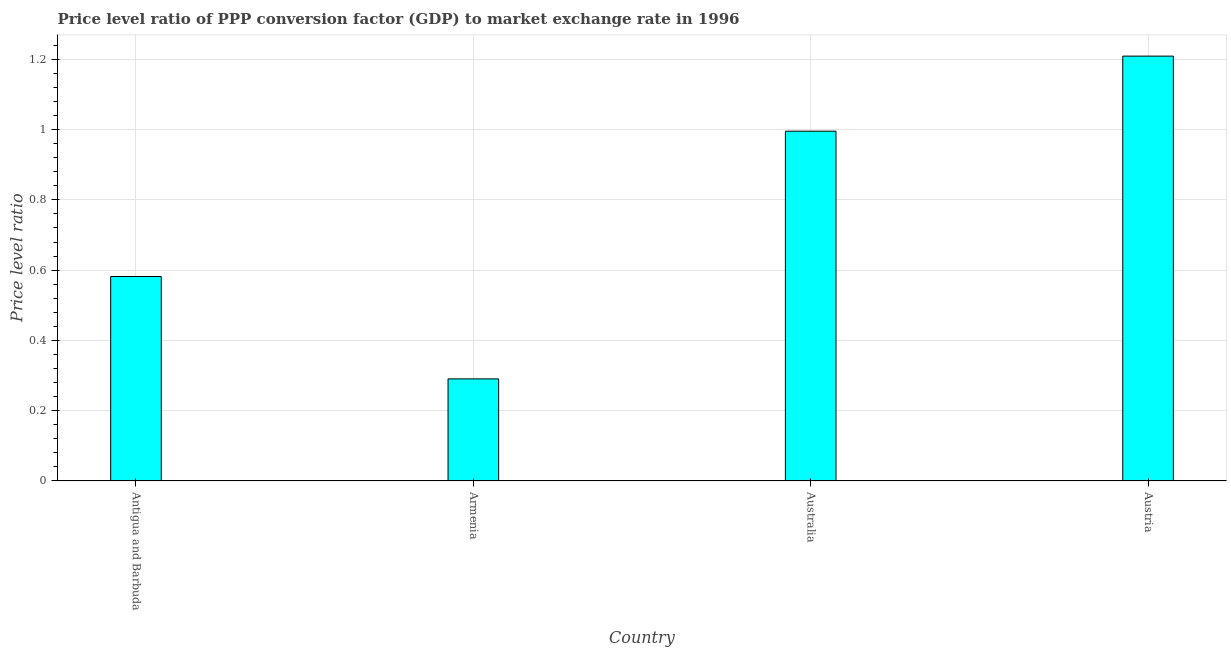Does the graph contain any zero values?
Your answer should be very brief. No. Does the graph contain grids?
Keep it short and to the point. Yes. What is the title of the graph?
Your answer should be very brief. Price level ratio of PPP conversion factor (GDP) to market exchange rate in 1996. What is the label or title of the Y-axis?
Your response must be concise. Price level ratio. What is the price level ratio in Australia?
Your answer should be compact. 1. Across all countries, what is the maximum price level ratio?
Keep it short and to the point. 1.21. Across all countries, what is the minimum price level ratio?
Offer a very short reply. 0.29. In which country was the price level ratio minimum?
Provide a short and direct response. Armenia. What is the sum of the price level ratio?
Your response must be concise. 3.08. What is the difference between the price level ratio in Antigua and Barbuda and Australia?
Your answer should be compact. -0.41. What is the average price level ratio per country?
Ensure brevity in your answer.  0.77. What is the median price level ratio?
Your answer should be very brief. 0.79. What is the ratio of the price level ratio in Armenia to that in Australia?
Your answer should be very brief. 0.29. Is the price level ratio in Antigua and Barbuda less than that in Australia?
Your answer should be very brief. Yes. Is the difference between the price level ratio in Antigua and Barbuda and Austria greater than the difference between any two countries?
Provide a succinct answer. No. What is the difference between the highest and the second highest price level ratio?
Give a very brief answer. 0.21. What is the difference between the highest and the lowest price level ratio?
Provide a succinct answer. 0.92. In how many countries, is the price level ratio greater than the average price level ratio taken over all countries?
Make the answer very short. 2. Are all the bars in the graph horizontal?
Your answer should be compact. No. How many countries are there in the graph?
Your answer should be compact. 4. What is the difference between two consecutive major ticks on the Y-axis?
Provide a succinct answer. 0.2. Are the values on the major ticks of Y-axis written in scientific E-notation?
Your answer should be very brief. No. What is the Price level ratio of Antigua and Barbuda?
Provide a succinct answer. 0.58. What is the Price level ratio of Armenia?
Ensure brevity in your answer.  0.29. What is the Price level ratio in Australia?
Offer a very short reply. 1. What is the Price level ratio of Austria?
Offer a very short reply. 1.21. What is the difference between the Price level ratio in Antigua and Barbuda and Armenia?
Offer a very short reply. 0.29. What is the difference between the Price level ratio in Antigua and Barbuda and Australia?
Give a very brief answer. -0.41. What is the difference between the Price level ratio in Antigua and Barbuda and Austria?
Make the answer very short. -0.63. What is the difference between the Price level ratio in Armenia and Australia?
Keep it short and to the point. -0.7. What is the difference between the Price level ratio in Armenia and Austria?
Ensure brevity in your answer.  -0.92. What is the difference between the Price level ratio in Australia and Austria?
Give a very brief answer. -0.21. What is the ratio of the Price level ratio in Antigua and Barbuda to that in Armenia?
Give a very brief answer. 2. What is the ratio of the Price level ratio in Antigua and Barbuda to that in Australia?
Your answer should be compact. 0.58. What is the ratio of the Price level ratio in Antigua and Barbuda to that in Austria?
Ensure brevity in your answer.  0.48. What is the ratio of the Price level ratio in Armenia to that in Australia?
Make the answer very short. 0.29. What is the ratio of the Price level ratio in Armenia to that in Austria?
Offer a very short reply. 0.24. What is the ratio of the Price level ratio in Australia to that in Austria?
Offer a terse response. 0.82. 